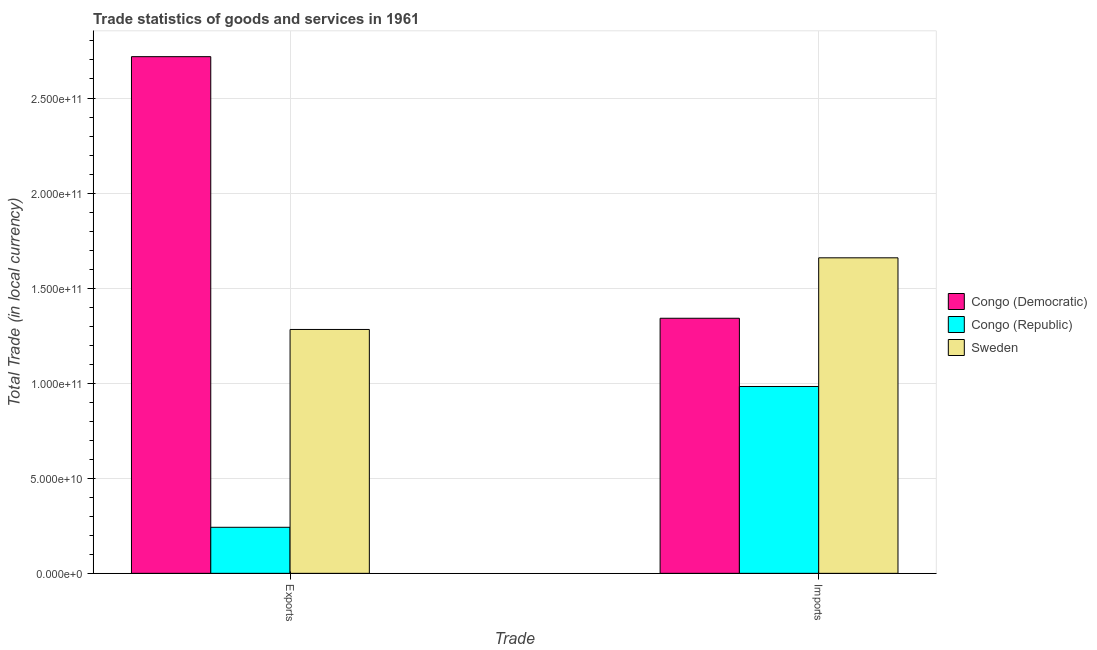How many different coloured bars are there?
Make the answer very short. 3. How many bars are there on the 1st tick from the left?
Provide a succinct answer. 3. What is the label of the 1st group of bars from the left?
Your response must be concise. Exports. What is the export of goods and services in Sweden?
Make the answer very short. 1.28e+11. Across all countries, what is the maximum export of goods and services?
Provide a succinct answer. 2.72e+11. Across all countries, what is the minimum imports of goods and services?
Provide a short and direct response. 9.83e+1. In which country was the imports of goods and services maximum?
Provide a short and direct response. Sweden. In which country was the imports of goods and services minimum?
Make the answer very short. Congo (Republic). What is the total imports of goods and services in the graph?
Your answer should be very brief. 3.98e+11. What is the difference between the export of goods and services in Sweden and that in Congo (Republic)?
Offer a terse response. 1.04e+11. What is the difference between the export of goods and services in Congo (Republic) and the imports of goods and services in Congo (Democratic)?
Your answer should be compact. -1.10e+11. What is the average imports of goods and services per country?
Provide a short and direct response. 1.33e+11. What is the difference between the export of goods and services and imports of goods and services in Congo (Democratic)?
Provide a short and direct response. 1.38e+11. In how many countries, is the imports of goods and services greater than 60000000000 LCU?
Give a very brief answer. 3. What is the ratio of the imports of goods and services in Congo (Democratic) to that in Sweden?
Your answer should be compact. 0.81. In how many countries, is the imports of goods and services greater than the average imports of goods and services taken over all countries?
Make the answer very short. 2. How many bars are there?
Give a very brief answer. 6. Are all the bars in the graph horizontal?
Provide a short and direct response. No. How many countries are there in the graph?
Your answer should be very brief. 3. Are the values on the major ticks of Y-axis written in scientific E-notation?
Offer a very short reply. Yes. Does the graph contain grids?
Make the answer very short. Yes. How many legend labels are there?
Keep it short and to the point. 3. How are the legend labels stacked?
Provide a short and direct response. Vertical. What is the title of the graph?
Provide a succinct answer. Trade statistics of goods and services in 1961. What is the label or title of the X-axis?
Provide a succinct answer. Trade. What is the label or title of the Y-axis?
Your response must be concise. Total Trade (in local currency). What is the Total Trade (in local currency) in Congo (Democratic) in Exports?
Keep it short and to the point. 2.72e+11. What is the Total Trade (in local currency) of Congo (Republic) in Exports?
Your answer should be compact. 2.42e+1. What is the Total Trade (in local currency) in Sweden in Exports?
Ensure brevity in your answer.  1.28e+11. What is the Total Trade (in local currency) in Congo (Democratic) in Imports?
Ensure brevity in your answer.  1.34e+11. What is the Total Trade (in local currency) of Congo (Republic) in Imports?
Offer a terse response. 9.83e+1. What is the Total Trade (in local currency) in Sweden in Imports?
Your answer should be very brief. 1.66e+11. Across all Trade, what is the maximum Total Trade (in local currency) in Congo (Democratic)?
Make the answer very short. 2.72e+11. Across all Trade, what is the maximum Total Trade (in local currency) in Congo (Republic)?
Your response must be concise. 9.83e+1. Across all Trade, what is the maximum Total Trade (in local currency) in Sweden?
Your response must be concise. 1.66e+11. Across all Trade, what is the minimum Total Trade (in local currency) in Congo (Democratic)?
Your answer should be compact. 1.34e+11. Across all Trade, what is the minimum Total Trade (in local currency) in Congo (Republic)?
Your answer should be compact. 2.42e+1. Across all Trade, what is the minimum Total Trade (in local currency) in Sweden?
Your answer should be compact. 1.28e+11. What is the total Total Trade (in local currency) in Congo (Democratic) in the graph?
Your answer should be compact. 4.06e+11. What is the total Total Trade (in local currency) in Congo (Republic) in the graph?
Ensure brevity in your answer.  1.22e+11. What is the total Total Trade (in local currency) in Sweden in the graph?
Offer a terse response. 2.94e+11. What is the difference between the Total Trade (in local currency) of Congo (Democratic) in Exports and that in Imports?
Give a very brief answer. 1.38e+11. What is the difference between the Total Trade (in local currency) in Congo (Republic) in Exports and that in Imports?
Give a very brief answer. -7.41e+1. What is the difference between the Total Trade (in local currency) of Sweden in Exports and that in Imports?
Your answer should be very brief. -3.77e+1. What is the difference between the Total Trade (in local currency) of Congo (Democratic) in Exports and the Total Trade (in local currency) of Congo (Republic) in Imports?
Provide a succinct answer. 1.73e+11. What is the difference between the Total Trade (in local currency) of Congo (Democratic) in Exports and the Total Trade (in local currency) of Sweden in Imports?
Your answer should be compact. 1.06e+11. What is the difference between the Total Trade (in local currency) in Congo (Republic) in Exports and the Total Trade (in local currency) in Sweden in Imports?
Provide a succinct answer. -1.42e+11. What is the average Total Trade (in local currency) of Congo (Democratic) per Trade?
Your answer should be compact. 2.03e+11. What is the average Total Trade (in local currency) in Congo (Republic) per Trade?
Your response must be concise. 6.12e+1. What is the average Total Trade (in local currency) in Sweden per Trade?
Provide a succinct answer. 1.47e+11. What is the difference between the Total Trade (in local currency) in Congo (Democratic) and Total Trade (in local currency) in Congo (Republic) in Exports?
Keep it short and to the point. 2.48e+11. What is the difference between the Total Trade (in local currency) of Congo (Democratic) and Total Trade (in local currency) of Sweden in Exports?
Provide a short and direct response. 1.43e+11. What is the difference between the Total Trade (in local currency) of Congo (Republic) and Total Trade (in local currency) of Sweden in Exports?
Give a very brief answer. -1.04e+11. What is the difference between the Total Trade (in local currency) in Congo (Democratic) and Total Trade (in local currency) in Congo (Republic) in Imports?
Ensure brevity in your answer.  3.59e+1. What is the difference between the Total Trade (in local currency) in Congo (Democratic) and Total Trade (in local currency) in Sweden in Imports?
Provide a succinct answer. -3.18e+1. What is the difference between the Total Trade (in local currency) in Congo (Republic) and Total Trade (in local currency) in Sweden in Imports?
Offer a terse response. -6.77e+1. What is the ratio of the Total Trade (in local currency) of Congo (Democratic) in Exports to that in Imports?
Your response must be concise. 2.03. What is the ratio of the Total Trade (in local currency) in Congo (Republic) in Exports to that in Imports?
Give a very brief answer. 0.25. What is the ratio of the Total Trade (in local currency) in Sweden in Exports to that in Imports?
Make the answer very short. 0.77. What is the difference between the highest and the second highest Total Trade (in local currency) of Congo (Democratic)?
Offer a terse response. 1.38e+11. What is the difference between the highest and the second highest Total Trade (in local currency) of Congo (Republic)?
Give a very brief answer. 7.41e+1. What is the difference between the highest and the second highest Total Trade (in local currency) of Sweden?
Provide a succinct answer. 3.77e+1. What is the difference between the highest and the lowest Total Trade (in local currency) in Congo (Democratic)?
Ensure brevity in your answer.  1.38e+11. What is the difference between the highest and the lowest Total Trade (in local currency) of Congo (Republic)?
Provide a short and direct response. 7.41e+1. What is the difference between the highest and the lowest Total Trade (in local currency) in Sweden?
Your answer should be compact. 3.77e+1. 